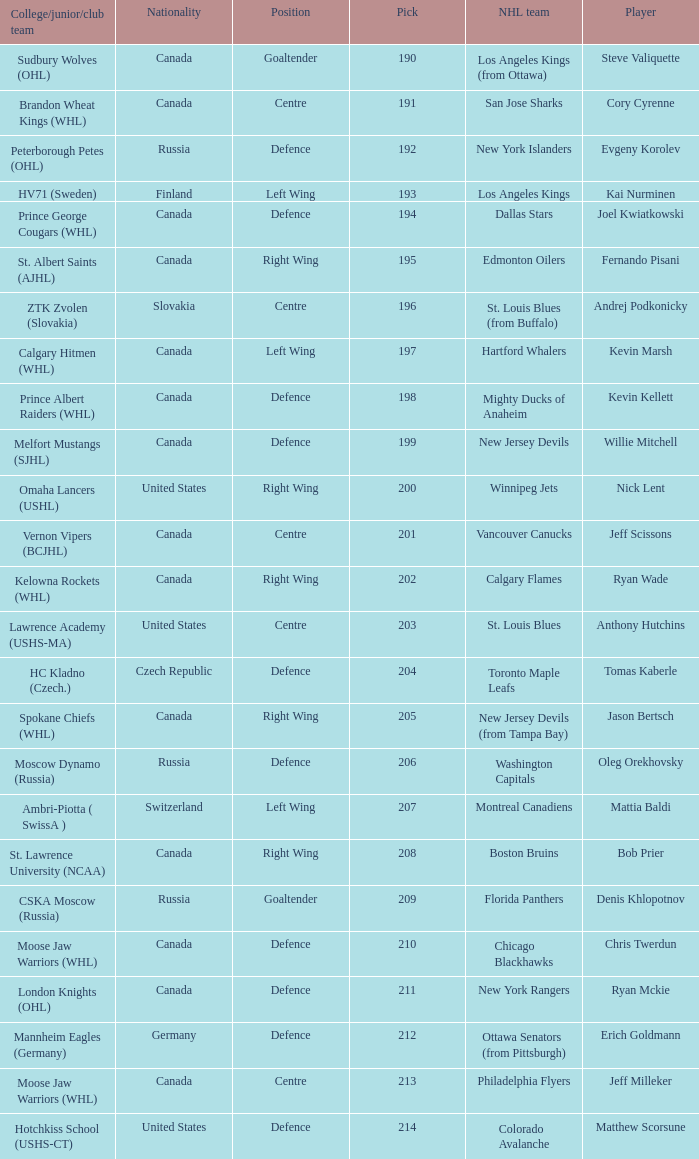Name the pick for matthew scorsune 214.0. 